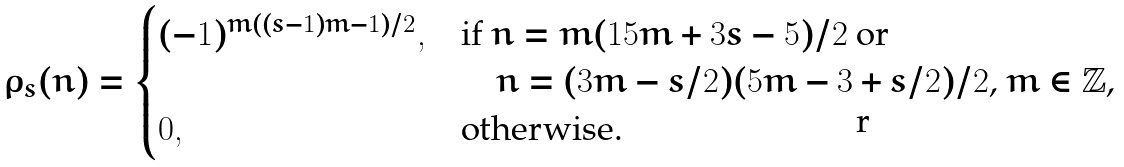<formula> <loc_0><loc_0><loc_500><loc_500>\rho _ { s } ( n ) = \begin{cases} ( - 1 ) ^ { m ( ( s - 1 ) m - 1 ) / 2 } , & \text {if $n=m(15m+3s-5)/2$ or} \\ & \text {\quad $n=(3m-s/2)(5m-3+s/2)/2$, $m\in\mathbb{Z}$,} \\ 0 , & \text {otherwise.} \end{cases}</formula> 